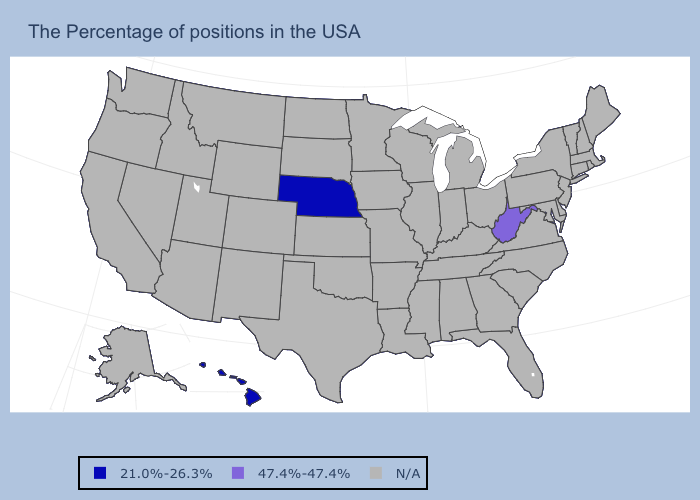What is the value of California?
Short answer required. N/A. Which states have the highest value in the USA?
Be succinct. West Virginia. Which states have the highest value in the USA?
Write a very short answer. West Virginia. Name the states that have a value in the range 47.4%-47.4%?
Write a very short answer. West Virginia. What is the value of Alabama?
Short answer required. N/A. Name the states that have a value in the range N/A?
Quick response, please. Maine, Massachusetts, Rhode Island, New Hampshire, Vermont, Connecticut, New York, New Jersey, Delaware, Maryland, Pennsylvania, Virginia, North Carolina, South Carolina, Ohio, Florida, Georgia, Michigan, Kentucky, Indiana, Alabama, Tennessee, Wisconsin, Illinois, Mississippi, Louisiana, Missouri, Arkansas, Minnesota, Iowa, Kansas, Oklahoma, Texas, South Dakota, North Dakota, Wyoming, Colorado, New Mexico, Utah, Montana, Arizona, Idaho, Nevada, California, Washington, Oregon, Alaska. Name the states that have a value in the range 47.4%-47.4%?
Quick response, please. West Virginia. What is the highest value in the South ?
Write a very short answer. 47.4%-47.4%. Does the map have missing data?
Be succinct. Yes. What is the highest value in the USA?
Short answer required. 47.4%-47.4%. Name the states that have a value in the range 21.0%-26.3%?
Short answer required. Nebraska, Hawaii. 